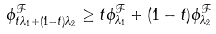Convert formula to latex. <formula><loc_0><loc_0><loc_500><loc_500>\phi _ { t \lambda _ { 1 } + ( 1 - t ) \lambda _ { 2 } } ^ { \mathcal { F } } \geq t \phi _ { \lambda _ { 1 } } ^ { \mathcal { F } } + ( 1 - t ) \phi _ { \lambda _ { 2 } } ^ { \mathcal { F } }</formula> 